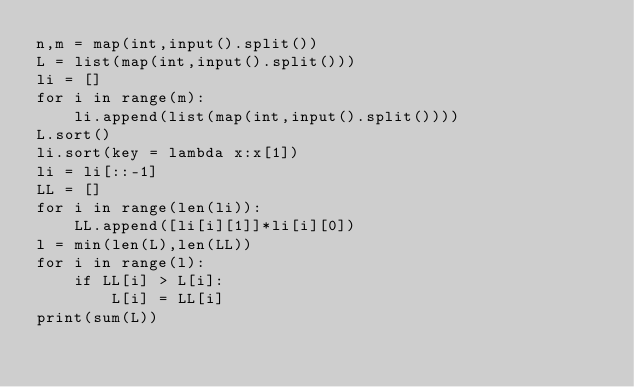<code> <loc_0><loc_0><loc_500><loc_500><_Python_>n,m = map(int,input().split())
L = list(map(int,input().split()))
li = []
for i in range(m):
    li.append(list(map(int,input().split())))
L.sort()
li.sort(key = lambda x:x[1])
li = li[::-1]
LL = []
for i in range(len(li)):
    LL.append([li[i][1]]*li[i][0])
l = min(len(L),len(LL))
for i in range(l):
    if LL[i] > L[i]:
        L[i] = LL[i]
print(sum(L))</code> 